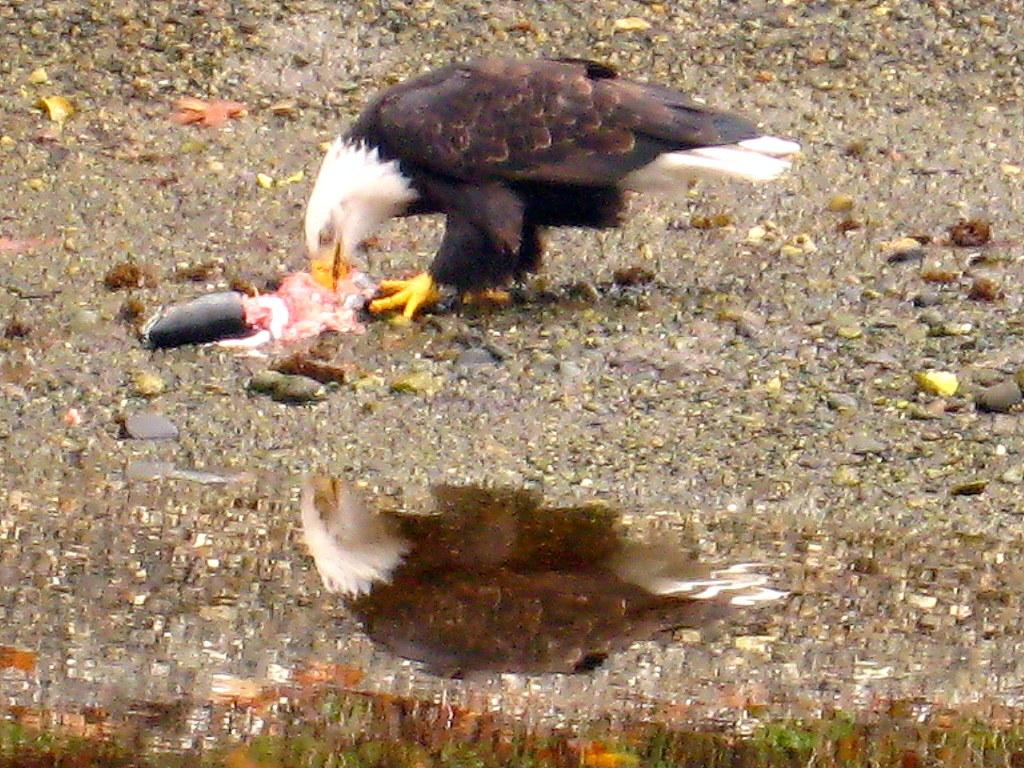What type of animal can be seen in the image? There is a bird in the image. Can you describe the bird's coloring? The bird has brown, black, and white colors. Where is the bird located in the image? The bird is on the ground. What else can be seen in the image besides the bird? There is water visible in the image. What rule does the bird follow when jumping in the image? There is no indication that the bird is jumping in the image, and therefore no rule can be determined. 